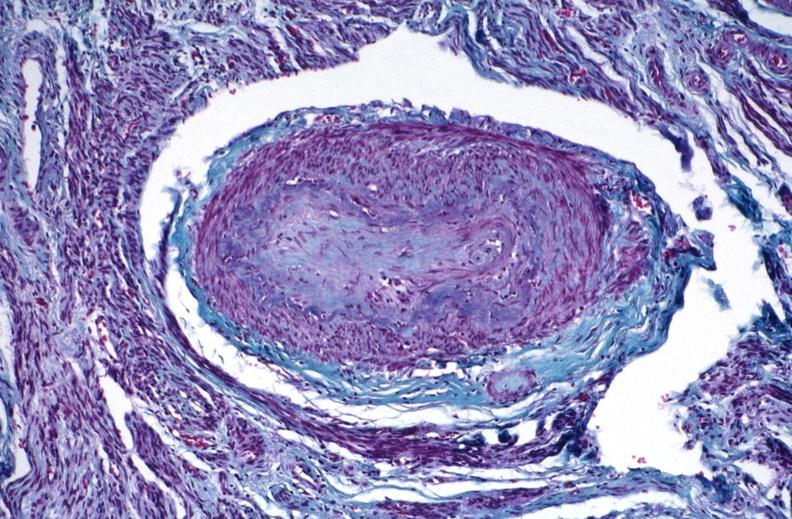does thigh at autopsy show kidney, polyarteritis nodosa?
Answer the question using a single word or phrase. No 